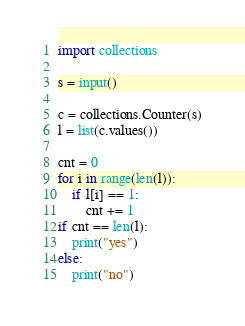Convert code to text. <code><loc_0><loc_0><loc_500><loc_500><_Python_>import collections

s = input()

c = collections.Counter(s)
l = list(c.values())

cnt = 0
for i in range(len(l)):
    if l[i] == 1:
        cnt += 1
if cnt == len(l):
    print("yes")
else:
    print("no")
</code> 